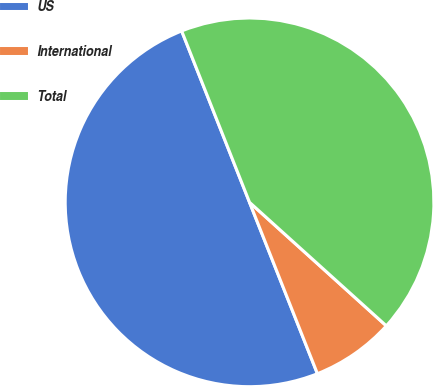Convert chart. <chart><loc_0><loc_0><loc_500><loc_500><pie_chart><fcel>US<fcel>International<fcel>Total<nl><fcel>50.0%<fcel>7.31%<fcel>42.69%<nl></chart> 